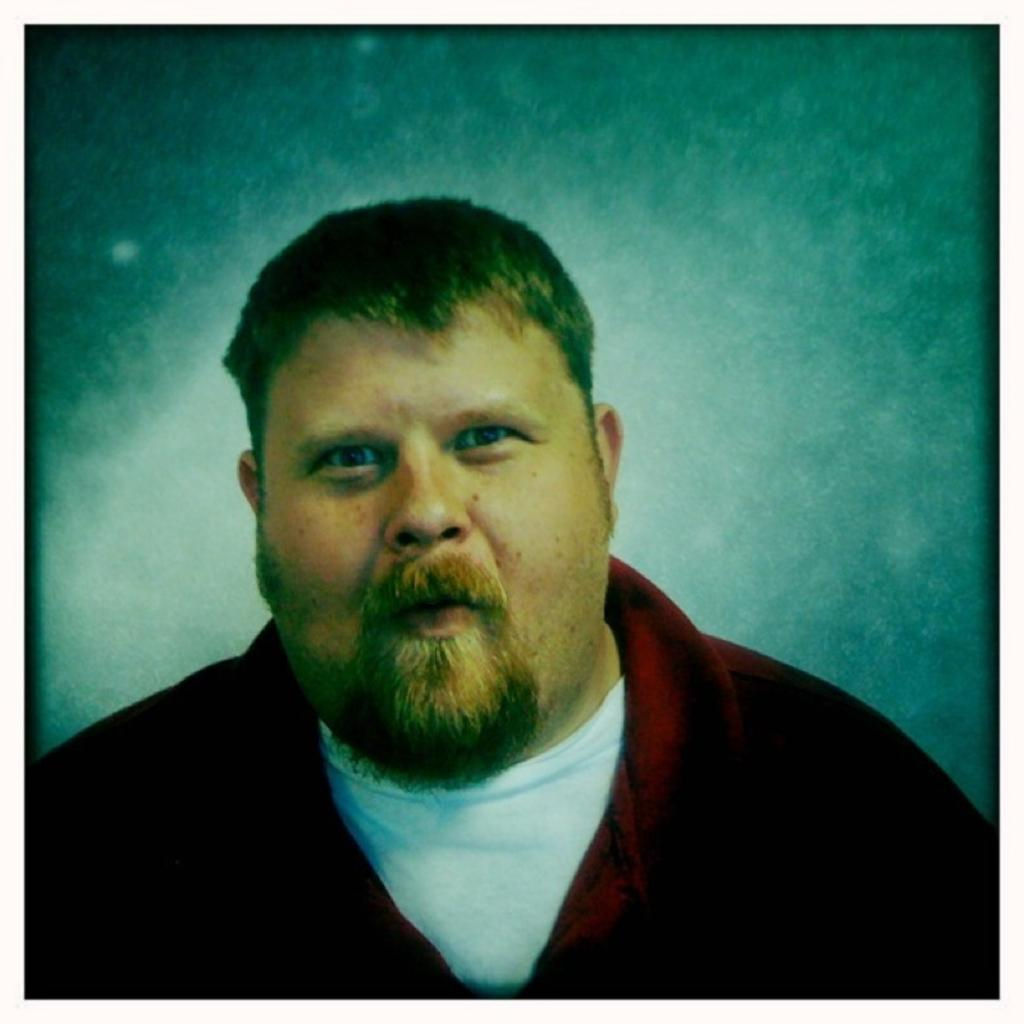What is present in the image? There is a person in the image. Can you describe the person's attire? The person is wearing clothes. What type of paint is being used by the women in the image? There are no women or paint present in the image; it only features a person wearing clothes. 